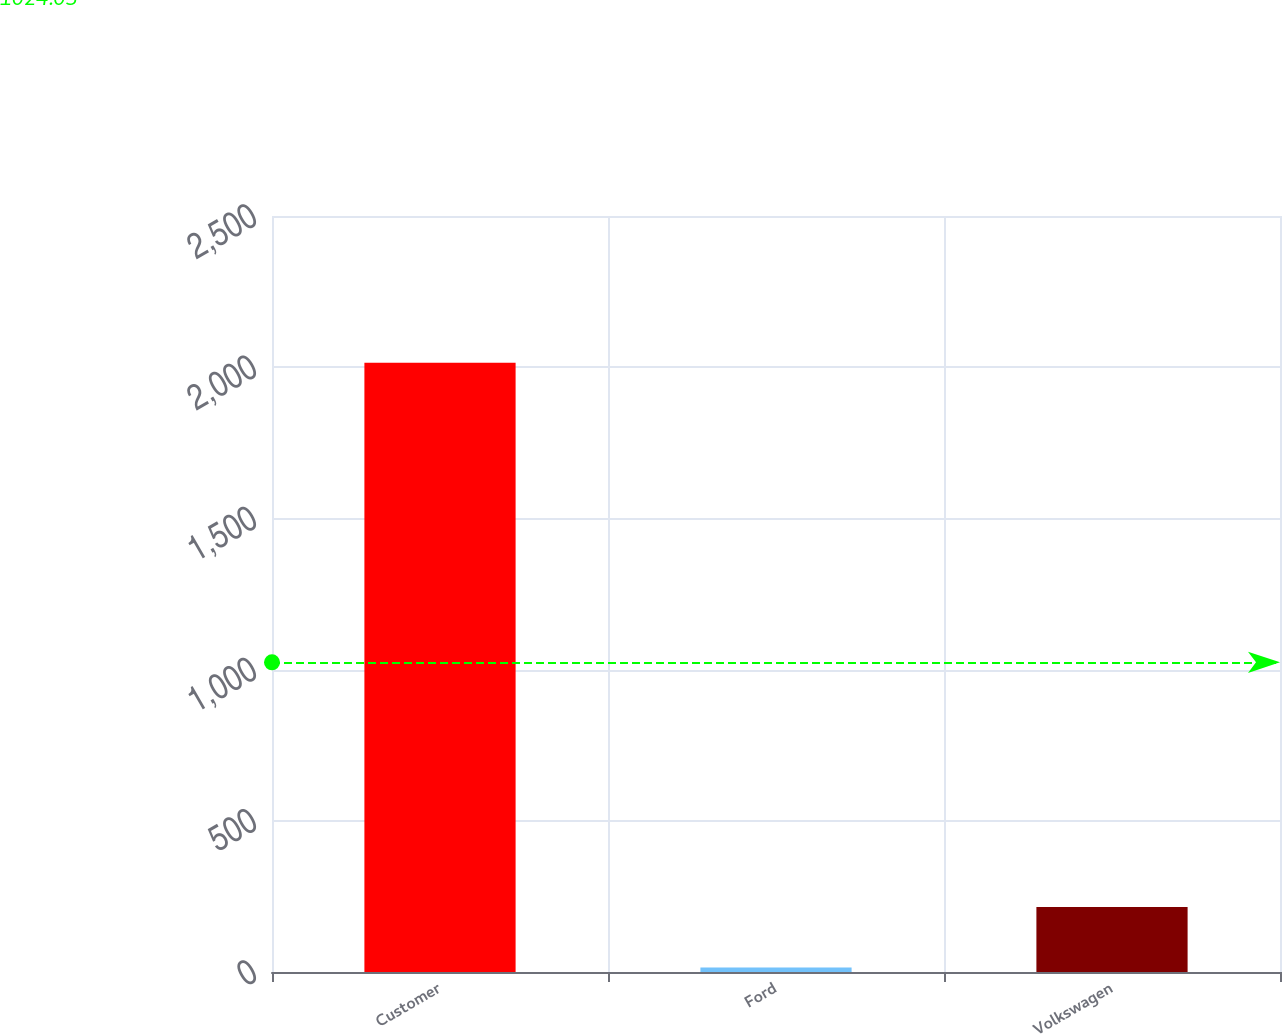Convert chart. <chart><loc_0><loc_0><loc_500><loc_500><bar_chart><fcel>Customer<fcel>Ford<fcel>Volkswagen<nl><fcel>2015<fcel>15<fcel>215<nl></chart> 